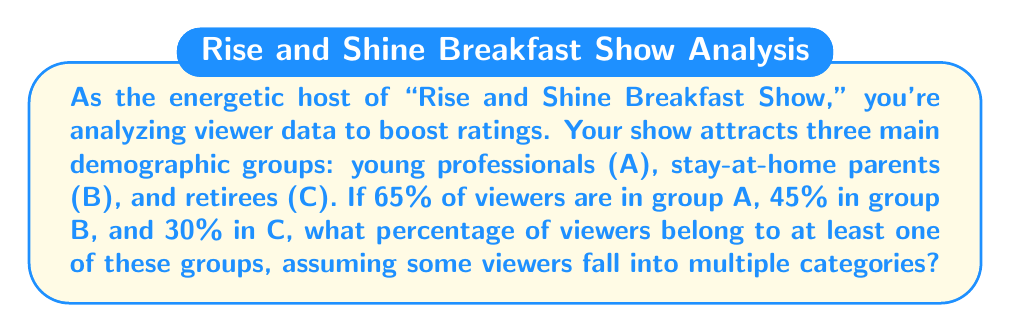Can you solve this math problem? Let's approach this step-by-step using Boolean algebra:

1) First, we need to understand what the percentages mean in Boolean terms:
   $P(A) = 0.65$, $P(B) = 0.45$, $P(C) = 0.30$

2) We want to find $P(A \cup B \cup C)$, which represents the probability of a viewer belonging to at least one group.

3) Using the inclusion-exclusion principle:

   $P(A \cup B \cup C) = P(A) + P(B) + P(C) - P(A \cap B) - P(A \cap C) - P(B \cap C) + P(A \cap B \cap C)$

4) We don't know the intersections, but we can use the given total to find them:

   $P(A) + P(B) + P(C) = 0.65 + 0.45 + 0.30 = 1.40$

5) This sum exceeds 1, indicating overlap between groups. The excess (0.40) represents the sum of all intersections:

   $P(A \cap B) + P(A \cap C) + P(B \cap C) - 2P(A \cap B \cap C) = 0.40$

6) Substituting this into our original equation:

   $P(A \cup B \cup C) = 1.40 - 0.40 = 1.00$

7) Converting to a percentage:

   $1.00 * 100\% = 100\%$
Answer: 100% 